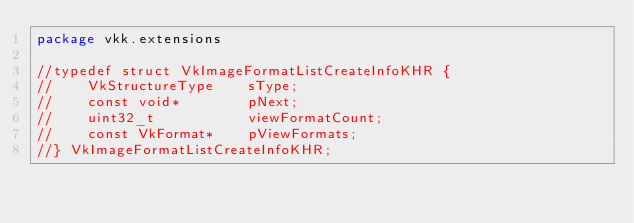Convert code to text. <code><loc_0><loc_0><loc_500><loc_500><_Kotlin_>package vkk.extensions

//typedef struct VkImageFormatListCreateInfoKHR {
//    VkStructureType    sType;
//    const void*        pNext;
//    uint32_t           viewFormatCount;
//    const VkFormat*    pViewFormats;
//} VkImageFormatListCreateInfoKHR;
</code> 